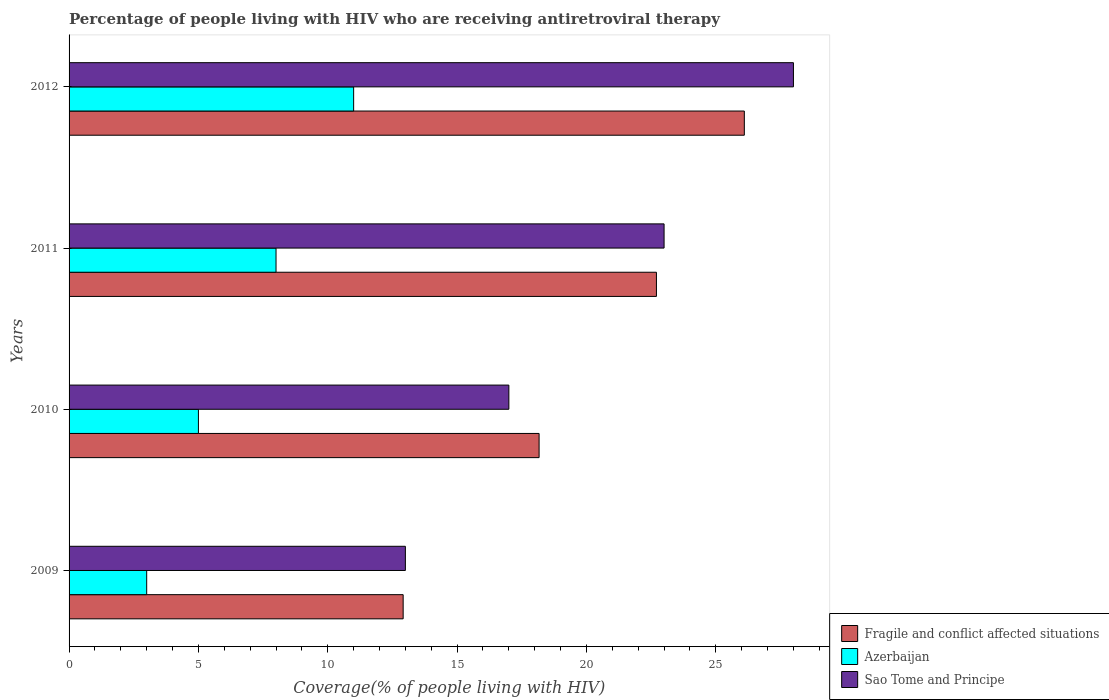How many bars are there on the 2nd tick from the top?
Give a very brief answer. 3. How many bars are there on the 2nd tick from the bottom?
Make the answer very short. 3. What is the label of the 4th group of bars from the top?
Make the answer very short. 2009. What is the percentage of the HIV infected people who are receiving antiretroviral therapy in Sao Tome and Principe in 2011?
Offer a terse response. 23. Across all years, what is the maximum percentage of the HIV infected people who are receiving antiretroviral therapy in Azerbaijan?
Give a very brief answer. 11. Across all years, what is the minimum percentage of the HIV infected people who are receiving antiretroviral therapy in Sao Tome and Principe?
Keep it short and to the point. 13. In which year was the percentage of the HIV infected people who are receiving antiretroviral therapy in Sao Tome and Principe minimum?
Ensure brevity in your answer.  2009. What is the total percentage of the HIV infected people who are receiving antiretroviral therapy in Azerbaijan in the graph?
Offer a very short reply. 27. What is the difference between the percentage of the HIV infected people who are receiving antiretroviral therapy in Sao Tome and Principe in 2009 and that in 2012?
Keep it short and to the point. -15. What is the difference between the percentage of the HIV infected people who are receiving antiretroviral therapy in Sao Tome and Principe in 2010 and the percentage of the HIV infected people who are receiving antiretroviral therapy in Azerbaijan in 2009?
Offer a terse response. 14. What is the average percentage of the HIV infected people who are receiving antiretroviral therapy in Azerbaijan per year?
Ensure brevity in your answer.  6.75. In the year 2009, what is the difference between the percentage of the HIV infected people who are receiving antiretroviral therapy in Fragile and conflict affected situations and percentage of the HIV infected people who are receiving antiretroviral therapy in Sao Tome and Principe?
Make the answer very short. -0.09. What is the ratio of the percentage of the HIV infected people who are receiving antiretroviral therapy in Fragile and conflict affected situations in 2011 to that in 2012?
Offer a terse response. 0.87. What is the difference between the highest and the lowest percentage of the HIV infected people who are receiving antiretroviral therapy in Sao Tome and Principe?
Your response must be concise. 15. In how many years, is the percentage of the HIV infected people who are receiving antiretroviral therapy in Sao Tome and Principe greater than the average percentage of the HIV infected people who are receiving antiretroviral therapy in Sao Tome and Principe taken over all years?
Offer a very short reply. 2. What does the 1st bar from the top in 2011 represents?
Keep it short and to the point. Sao Tome and Principe. What does the 1st bar from the bottom in 2009 represents?
Provide a short and direct response. Fragile and conflict affected situations. Is it the case that in every year, the sum of the percentage of the HIV infected people who are receiving antiretroviral therapy in Fragile and conflict affected situations and percentage of the HIV infected people who are receiving antiretroviral therapy in Azerbaijan is greater than the percentage of the HIV infected people who are receiving antiretroviral therapy in Sao Tome and Principe?
Offer a terse response. Yes. Are all the bars in the graph horizontal?
Your answer should be very brief. Yes. What is the difference between two consecutive major ticks on the X-axis?
Offer a terse response. 5. Are the values on the major ticks of X-axis written in scientific E-notation?
Offer a terse response. No. Does the graph contain any zero values?
Provide a succinct answer. No. Where does the legend appear in the graph?
Your response must be concise. Bottom right. What is the title of the graph?
Give a very brief answer. Percentage of people living with HIV who are receiving antiretroviral therapy. Does "Hong Kong" appear as one of the legend labels in the graph?
Your answer should be compact. No. What is the label or title of the X-axis?
Offer a terse response. Coverage(% of people living with HIV). What is the Coverage(% of people living with HIV) of Fragile and conflict affected situations in 2009?
Offer a terse response. 12.91. What is the Coverage(% of people living with HIV) in Fragile and conflict affected situations in 2010?
Keep it short and to the point. 18.17. What is the Coverage(% of people living with HIV) in Sao Tome and Principe in 2010?
Offer a terse response. 17. What is the Coverage(% of people living with HIV) in Fragile and conflict affected situations in 2011?
Provide a succinct answer. 22.7. What is the Coverage(% of people living with HIV) in Azerbaijan in 2011?
Provide a short and direct response. 8. What is the Coverage(% of people living with HIV) of Sao Tome and Principe in 2011?
Offer a terse response. 23. What is the Coverage(% of people living with HIV) in Fragile and conflict affected situations in 2012?
Give a very brief answer. 26.1. What is the Coverage(% of people living with HIV) in Sao Tome and Principe in 2012?
Provide a short and direct response. 28. Across all years, what is the maximum Coverage(% of people living with HIV) in Fragile and conflict affected situations?
Offer a very short reply. 26.1. Across all years, what is the maximum Coverage(% of people living with HIV) in Azerbaijan?
Provide a short and direct response. 11. Across all years, what is the maximum Coverage(% of people living with HIV) in Sao Tome and Principe?
Your answer should be very brief. 28. Across all years, what is the minimum Coverage(% of people living with HIV) of Fragile and conflict affected situations?
Offer a terse response. 12.91. Across all years, what is the minimum Coverage(% of people living with HIV) of Sao Tome and Principe?
Make the answer very short. 13. What is the total Coverage(% of people living with HIV) in Fragile and conflict affected situations in the graph?
Provide a succinct answer. 79.89. What is the total Coverage(% of people living with HIV) of Azerbaijan in the graph?
Offer a very short reply. 27. What is the total Coverage(% of people living with HIV) of Sao Tome and Principe in the graph?
Offer a terse response. 81. What is the difference between the Coverage(% of people living with HIV) of Fragile and conflict affected situations in 2009 and that in 2010?
Give a very brief answer. -5.25. What is the difference between the Coverage(% of people living with HIV) of Azerbaijan in 2009 and that in 2010?
Provide a succinct answer. -2. What is the difference between the Coverage(% of people living with HIV) of Sao Tome and Principe in 2009 and that in 2010?
Your answer should be compact. -4. What is the difference between the Coverage(% of people living with HIV) of Fragile and conflict affected situations in 2009 and that in 2011?
Make the answer very short. -9.79. What is the difference between the Coverage(% of people living with HIV) of Azerbaijan in 2009 and that in 2011?
Your answer should be compact. -5. What is the difference between the Coverage(% of people living with HIV) in Fragile and conflict affected situations in 2009 and that in 2012?
Make the answer very short. -13.19. What is the difference between the Coverage(% of people living with HIV) in Azerbaijan in 2009 and that in 2012?
Your response must be concise. -8. What is the difference between the Coverage(% of people living with HIV) in Fragile and conflict affected situations in 2010 and that in 2011?
Offer a terse response. -4.54. What is the difference between the Coverage(% of people living with HIV) in Azerbaijan in 2010 and that in 2011?
Provide a succinct answer. -3. What is the difference between the Coverage(% of people living with HIV) in Sao Tome and Principe in 2010 and that in 2011?
Your answer should be compact. -6. What is the difference between the Coverage(% of people living with HIV) of Fragile and conflict affected situations in 2010 and that in 2012?
Give a very brief answer. -7.93. What is the difference between the Coverage(% of people living with HIV) in Fragile and conflict affected situations in 2011 and that in 2012?
Offer a terse response. -3.4. What is the difference between the Coverage(% of people living with HIV) in Azerbaijan in 2011 and that in 2012?
Your response must be concise. -3. What is the difference between the Coverage(% of people living with HIV) of Sao Tome and Principe in 2011 and that in 2012?
Offer a very short reply. -5. What is the difference between the Coverage(% of people living with HIV) in Fragile and conflict affected situations in 2009 and the Coverage(% of people living with HIV) in Azerbaijan in 2010?
Keep it short and to the point. 7.91. What is the difference between the Coverage(% of people living with HIV) in Fragile and conflict affected situations in 2009 and the Coverage(% of people living with HIV) in Sao Tome and Principe in 2010?
Your answer should be very brief. -4.09. What is the difference between the Coverage(% of people living with HIV) in Azerbaijan in 2009 and the Coverage(% of people living with HIV) in Sao Tome and Principe in 2010?
Provide a short and direct response. -14. What is the difference between the Coverage(% of people living with HIV) of Fragile and conflict affected situations in 2009 and the Coverage(% of people living with HIV) of Azerbaijan in 2011?
Make the answer very short. 4.91. What is the difference between the Coverage(% of people living with HIV) of Fragile and conflict affected situations in 2009 and the Coverage(% of people living with HIV) of Sao Tome and Principe in 2011?
Your answer should be very brief. -10.09. What is the difference between the Coverage(% of people living with HIV) of Fragile and conflict affected situations in 2009 and the Coverage(% of people living with HIV) of Azerbaijan in 2012?
Offer a very short reply. 1.91. What is the difference between the Coverage(% of people living with HIV) of Fragile and conflict affected situations in 2009 and the Coverage(% of people living with HIV) of Sao Tome and Principe in 2012?
Make the answer very short. -15.09. What is the difference between the Coverage(% of people living with HIV) in Azerbaijan in 2009 and the Coverage(% of people living with HIV) in Sao Tome and Principe in 2012?
Provide a short and direct response. -25. What is the difference between the Coverage(% of people living with HIV) in Fragile and conflict affected situations in 2010 and the Coverage(% of people living with HIV) in Azerbaijan in 2011?
Keep it short and to the point. 10.17. What is the difference between the Coverage(% of people living with HIV) of Fragile and conflict affected situations in 2010 and the Coverage(% of people living with HIV) of Sao Tome and Principe in 2011?
Offer a terse response. -4.83. What is the difference between the Coverage(% of people living with HIV) in Fragile and conflict affected situations in 2010 and the Coverage(% of people living with HIV) in Azerbaijan in 2012?
Your answer should be compact. 7.17. What is the difference between the Coverage(% of people living with HIV) in Fragile and conflict affected situations in 2010 and the Coverage(% of people living with HIV) in Sao Tome and Principe in 2012?
Your answer should be compact. -9.83. What is the difference between the Coverage(% of people living with HIV) in Fragile and conflict affected situations in 2011 and the Coverage(% of people living with HIV) in Azerbaijan in 2012?
Make the answer very short. 11.7. What is the difference between the Coverage(% of people living with HIV) of Fragile and conflict affected situations in 2011 and the Coverage(% of people living with HIV) of Sao Tome and Principe in 2012?
Ensure brevity in your answer.  -5.3. What is the difference between the Coverage(% of people living with HIV) in Azerbaijan in 2011 and the Coverage(% of people living with HIV) in Sao Tome and Principe in 2012?
Make the answer very short. -20. What is the average Coverage(% of people living with HIV) of Fragile and conflict affected situations per year?
Offer a very short reply. 19.97. What is the average Coverage(% of people living with HIV) of Azerbaijan per year?
Your answer should be very brief. 6.75. What is the average Coverage(% of people living with HIV) in Sao Tome and Principe per year?
Your answer should be compact. 20.25. In the year 2009, what is the difference between the Coverage(% of people living with HIV) in Fragile and conflict affected situations and Coverage(% of people living with HIV) in Azerbaijan?
Ensure brevity in your answer.  9.91. In the year 2009, what is the difference between the Coverage(% of people living with HIV) of Fragile and conflict affected situations and Coverage(% of people living with HIV) of Sao Tome and Principe?
Offer a very short reply. -0.09. In the year 2010, what is the difference between the Coverage(% of people living with HIV) of Fragile and conflict affected situations and Coverage(% of people living with HIV) of Azerbaijan?
Ensure brevity in your answer.  13.17. In the year 2010, what is the difference between the Coverage(% of people living with HIV) of Fragile and conflict affected situations and Coverage(% of people living with HIV) of Sao Tome and Principe?
Provide a short and direct response. 1.17. In the year 2011, what is the difference between the Coverage(% of people living with HIV) in Fragile and conflict affected situations and Coverage(% of people living with HIV) in Azerbaijan?
Your response must be concise. 14.7. In the year 2011, what is the difference between the Coverage(% of people living with HIV) in Fragile and conflict affected situations and Coverage(% of people living with HIV) in Sao Tome and Principe?
Offer a terse response. -0.3. In the year 2011, what is the difference between the Coverage(% of people living with HIV) of Azerbaijan and Coverage(% of people living with HIV) of Sao Tome and Principe?
Your response must be concise. -15. In the year 2012, what is the difference between the Coverage(% of people living with HIV) of Fragile and conflict affected situations and Coverage(% of people living with HIV) of Azerbaijan?
Your answer should be very brief. 15.1. In the year 2012, what is the difference between the Coverage(% of people living with HIV) in Fragile and conflict affected situations and Coverage(% of people living with HIV) in Sao Tome and Principe?
Give a very brief answer. -1.9. In the year 2012, what is the difference between the Coverage(% of people living with HIV) of Azerbaijan and Coverage(% of people living with HIV) of Sao Tome and Principe?
Make the answer very short. -17. What is the ratio of the Coverage(% of people living with HIV) of Fragile and conflict affected situations in 2009 to that in 2010?
Give a very brief answer. 0.71. What is the ratio of the Coverage(% of people living with HIV) of Azerbaijan in 2009 to that in 2010?
Provide a succinct answer. 0.6. What is the ratio of the Coverage(% of people living with HIV) in Sao Tome and Principe in 2009 to that in 2010?
Give a very brief answer. 0.76. What is the ratio of the Coverage(% of people living with HIV) of Fragile and conflict affected situations in 2009 to that in 2011?
Provide a short and direct response. 0.57. What is the ratio of the Coverage(% of people living with HIV) of Sao Tome and Principe in 2009 to that in 2011?
Ensure brevity in your answer.  0.57. What is the ratio of the Coverage(% of people living with HIV) of Fragile and conflict affected situations in 2009 to that in 2012?
Offer a very short reply. 0.49. What is the ratio of the Coverage(% of people living with HIV) in Azerbaijan in 2009 to that in 2012?
Your answer should be very brief. 0.27. What is the ratio of the Coverage(% of people living with HIV) in Sao Tome and Principe in 2009 to that in 2012?
Provide a succinct answer. 0.46. What is the ratio of the Coverage(% of people living with HIV) of Fragile and conflict affected situations in 2010 to that in 2011?
Make the answer very short. 0.8. What is the ratio of the Coverage(% of people living with HIV) of Azerbaijan in 2010 to that in 2011?
Offer a very short reply. 0.62. What is the ratio of the Coverage(% of people living with HIV) in Sao Tome and Principe in 2010 to that in 2011?
Keep it short and to the point. 0.74. What is the ratio of the Coverage(% of people living with HIV) in Fragile and conflict affected situations in 2010 to that in 2012?
Keep it short and to the point. 0.7. What is the ratio of the Coverage(% of people living with HIV) of Azerbaijan in 2010 to that in 2012?
Your answer should be very brief. 0.45. What is the ratio of the Coverage(% of people living with HIV) in Sao Tome and Principe in 2010 to that in 2012?
Provide a succinct answer. 0.61. What is the ratio of the Coverage(% of people living with HIV) of Fragile and conflict affected situations in 2011 to that in 2012?
Your answer should be compact. 0.87. What is the ratio of the Coverage(% of people living with HIV) of Azerbaijan in 2011 to that in 2012?
Make the answer very short. 0.73. What is the ratio of the Coverage(% of people living with HIV) of Sao Tome and Principe in 2011 to that in 2012?
Ensure brevity in your answer.  0.82. What is the difference between the highest and the second highest Coverage(% of people living with HIV) in Fragile and conflict affected situations?
Keep it short and to the point. 3.4. What is the difference between the highest and the lowest Coverage(% of people living with HIV) in Fragile and conflict affected situations?
Your response must be concise. 13.19. What is the difference between the highest and the lowest Coverage(% of people living with HIV) of Azerbaijan?
Make the answer very short. 8. 